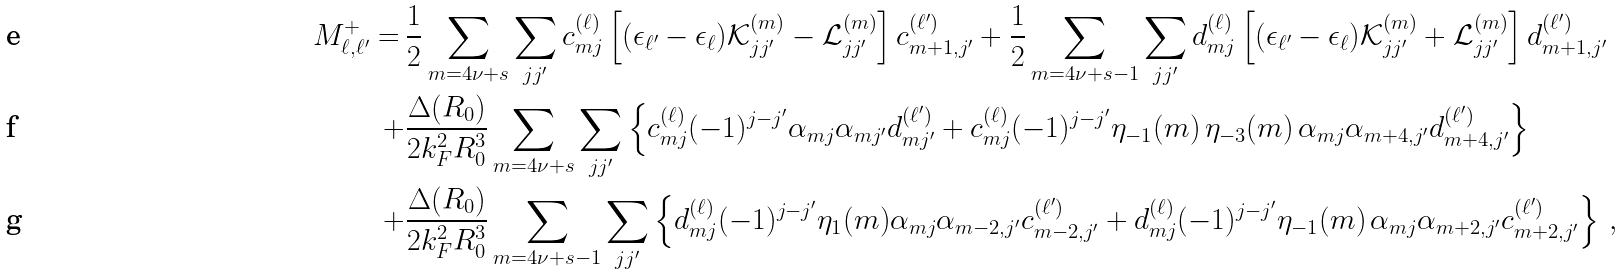Convert formula to latex. <formula><loc_0><loc_0><loc_500><loc_500>M _ { \ell , \ell ^ { \prime } } ^ { + } = \, & \frac { 1 } { 2 } \sum _ { m = 4 \nu + s } \sum _ { j j ^ { \prime } } c _ { m j } ^ { ( \ell ) } \left [ ( \epsilon _ { \ell ^ { \prime } } - \epsilon _ { \ell } ) \mathcal { K } _ { j j ^ { \prime } } ^ { ( m ) } - \mathcal { L } _ { j j ^ { \prime } } ^ { ( m ) } \right ] c _ { m + 1 , j ^ { \prime } } ^ { ( \ell ^ { \prime } ) } + \frac { 1 } { 2 } \sum _ { m = 4 \nu + s - 1 } \sum _ { j j ^ { \prime } } d _ { m j } ^ { ( \ell ) } \left [ ( \epsilon _ { \ell ^ { \prime } } - \epsilon _ { \ell } ) \mathcal { K } _ { j j ^ { \prime } } ^ { ( m ) } + \mathcal { L } _ { j j ^ { \prime } } ^ { ( m ) } \right ] d _ { m + 1 , j ^ { \prime } } ^ { ( \ell ^ { \prime } ) } \\ + & \frac { \Delta ( R _ { 0 } ) } { 2 k _ { F } ^ { 2 } R _ { 0 } ^ { 3 } } \sum _ { m = 4 \nu + s } \sum _ { j j ^ { \prime } } \left \{ c _ { m j } ^ { ( \ell ) } ( - 1 ) ^ { j - j ^ { \prime } } \alpha _ { m j } \alpha _ { m j ^ { \prime } } d _ { m j ^ { \prime } } ^ { ( \ell ^ { \prime } ) } + c _ { m j } ^ { ( \ell ) } ( - 1 ) ^ { j - j ^ { \prime } } \eta _ { - 1 } ( m ) \, \eta _ { - 3 } ( m ) \, \alpha _ { m j } \alpha _ { m + 4 , j ^ { \prime } } d _ { m + 4 , j ^ { \prime } } ^ { ( \ell ^ { \prime } ) } \right \} \\ + & \frac { \Delta ( R _ { 0 } ) } { 2 k _ { F } ^ { 2 } R _ { 0 } ^ { 3 } } \sum _ { m = 4 \nu + s - 1 } \sum _ { j j ^ { \prime } } \left \{ d _ { m j } ^ { ( \ell ) } ( - 1 ) ^ { j - j ^ { \prime } } \eta _ { 1 } ( m ) \alpha _ { m j } \alpha _ { m - 2 , j ^ { \prime } } c _ { m - 2 , j ^ { \prime } } ^ { ( \ell ^ { \prime } ) } + d _ { m j } ^ { ( \ell ) } ( - 1 ) ^ { j - j ^ { \prime } } \eta _ { - 1 } ( m ) \, \alpha _ { m j } \alpha _ { m + 2 , j ^ { \prime } } c _ { m + 2 , j ^ { \prime } } ^ { ( \ell ^ { \prime } ) } \right \} \, ,</formula> 